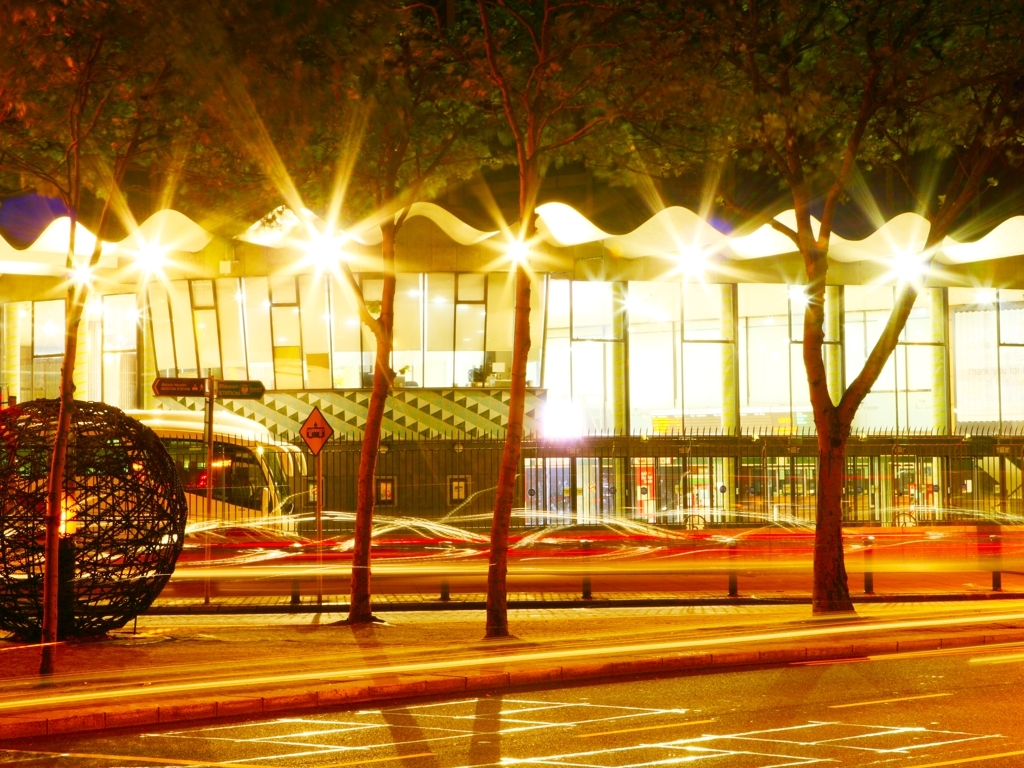What time of day does this photo seem to represent, and how can you tell? The photo likely represents nighttime. This is evidenced by the artificial lighting, such as the street lamps and vehicle lights, which are prominent features in the image. The darkness of the sky also suggests that it is after sunset. Can you describe the artistic elements present in this image? Certainly. The image exhibits a vivid interplay of static and dynamic elements. The motion blur of vehicle lights creates red and white streaks that contrast with the sharpness of the stationary objects like the rounded metallic sculpture, trees, and architecture. Furthermore, the reflective wet ground enhances the vibrancy of light, adding to the aesthetic appeal of the scene. 